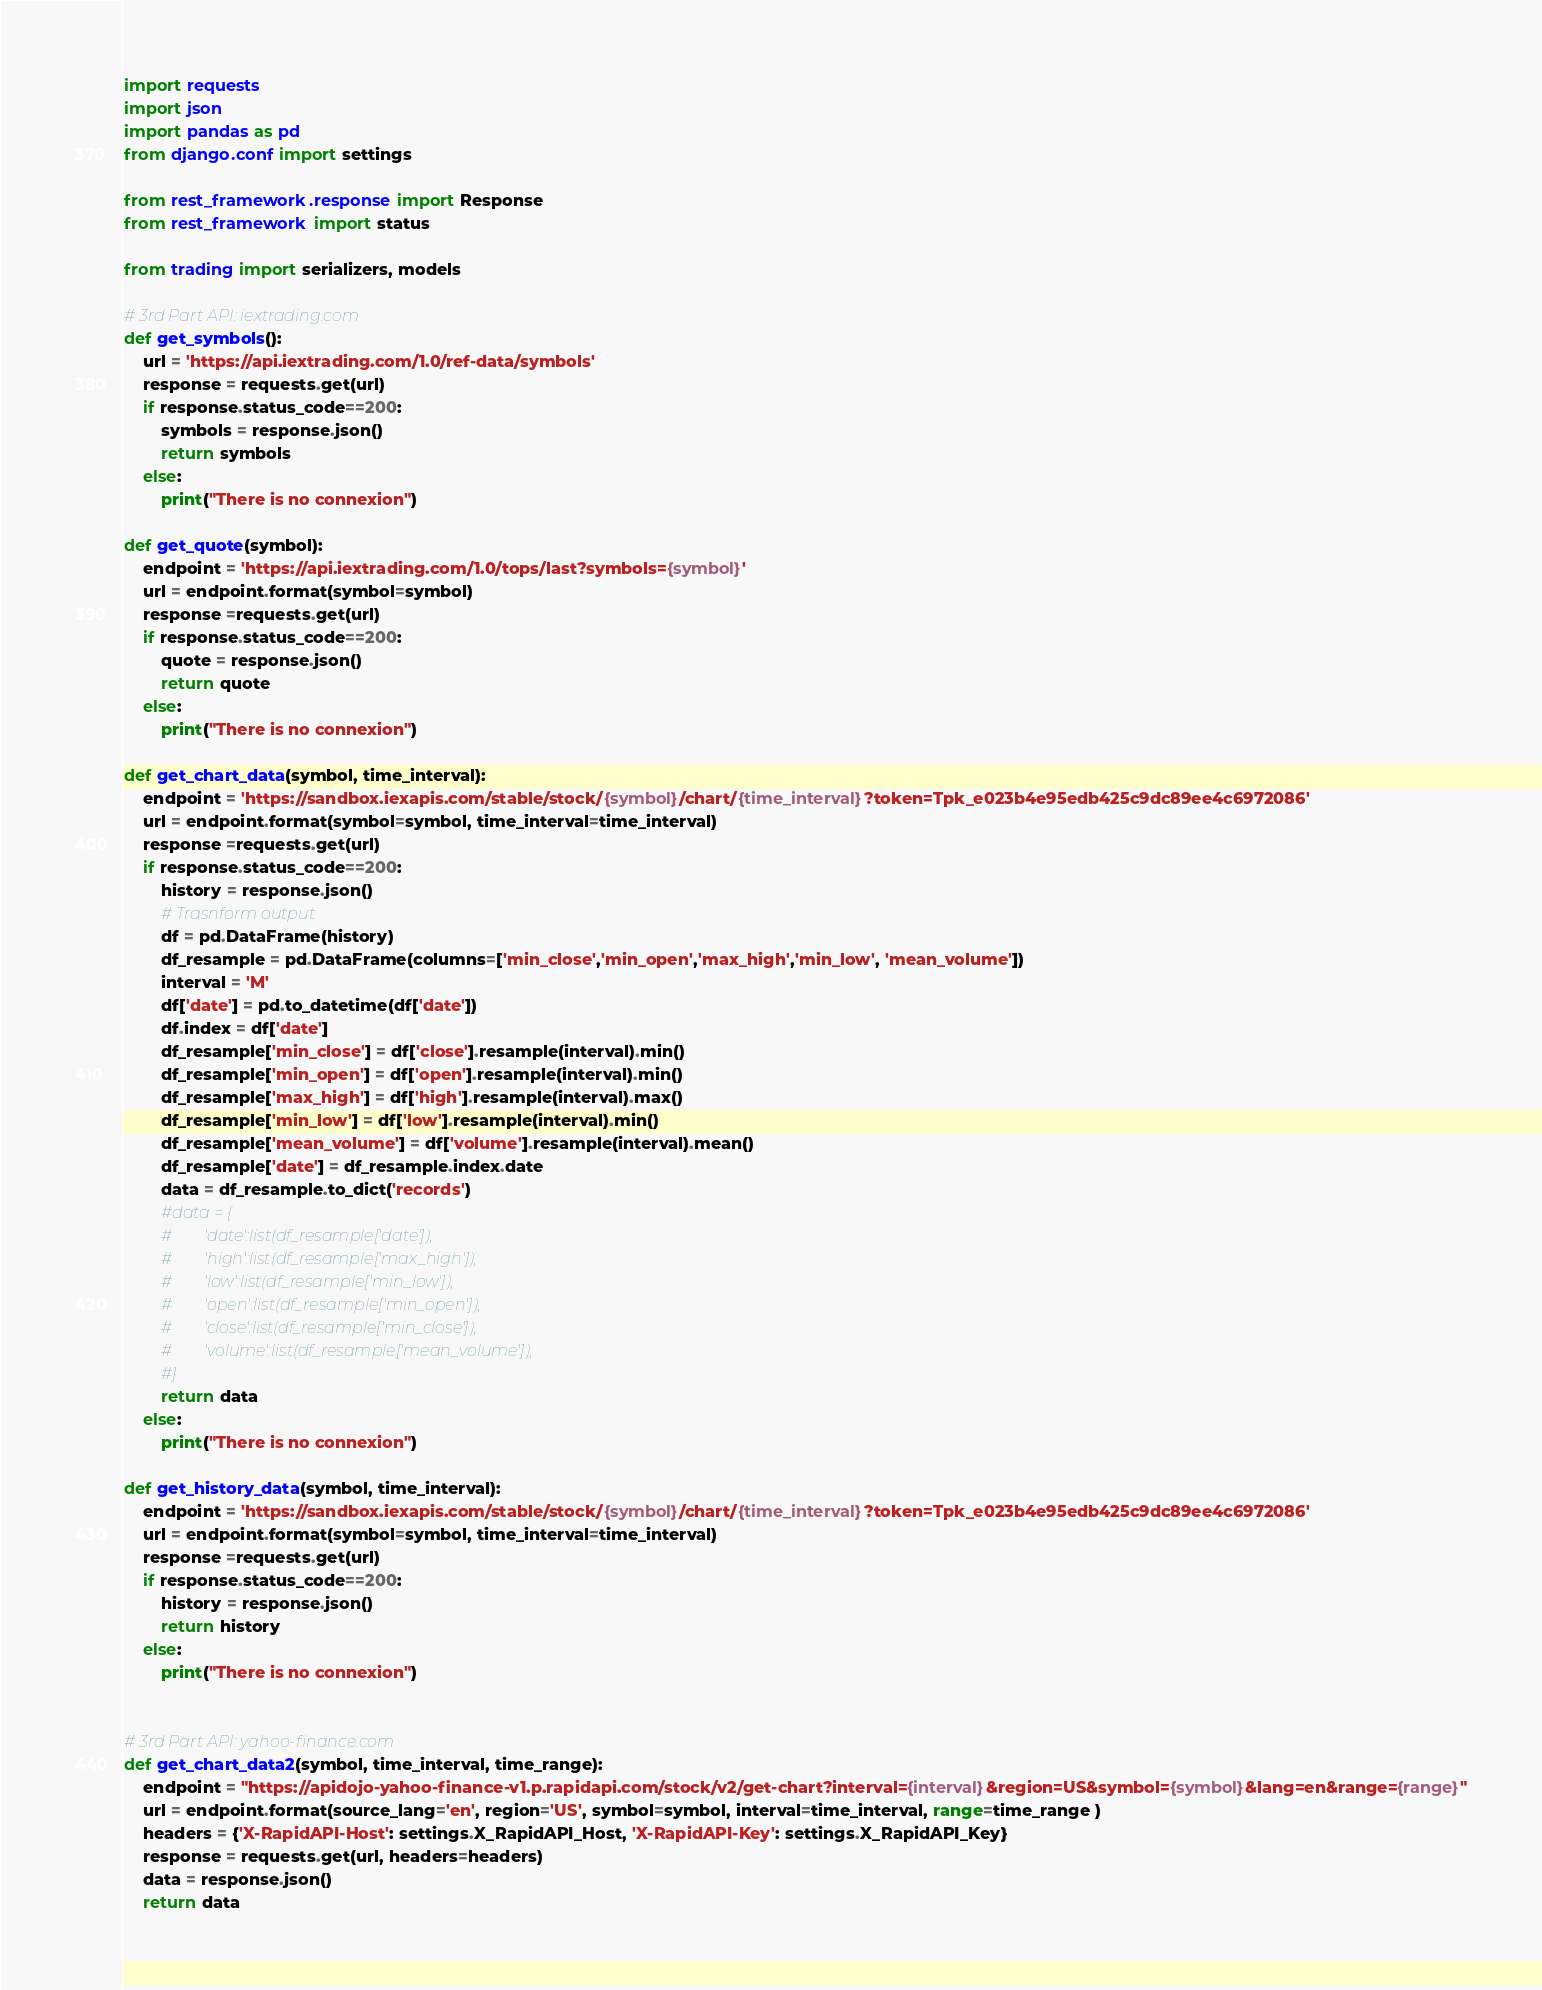Convert code to text. <code><loc_0><loc_0><loc_500><loc_500><_Python_>import requests
import json
import pandas as pd
from django.conf import settings

from rest_framework.response import Response
from rest_framework import status

from trading import serializers, models

# 3rd Part API: iextrading.com
def get_symbols():
    url = 'https://api.iextrading.com/1.0/ref-data/symbols'
    response = requests.get(url)
    if response.status_code==200:
        symbols = response.json()
        return symbols
    else:
        print("There is no connexion")

def get_quote(symbol):
    endpoint = 'https://api.iextrading.com/1.0/tops/last?symbols={symbol}'
    url = endpoint.format(symbol=symbol)
    response =requests.get(url)
    if response.status_code==200:
        quote = response.json()
        return quote
    else:
        print("There is no connexion")

def get_chart_data(symbol, time_interval):
    endpoint = 'https://sandbox.iexapis.com/stable/stock/{symbol}/chart/{time_interval}?token=Tpk_e023b4e95edb425c9dc89ee4c6972086'
    url = endpoint.format(symbol=symbol, time_interval=time_interval)
    response =requests.get(url)
    if response.status_code==200:
        history = response.json()
        # Trasnform output
        df = pd.DataFrame(history)
        df_resample = pd.DataFrame(columns=['min_close','min_open','max_high','min_low', 'mean_volume'])
        interval = 'M'
        df['date'] = pd.to_datetime(df['date'])
        df.index = df['date'] 
        df_resample['min_close'] = df['close'].resample(interval).min()
        df_resample['min_open'] = df['open'].resample(interval).min()
        df_resample['max_high'] = df['high'].resample(interval).max()
        df_resample['min_low'] = df['low'].resample(interval).min()
        df_resample['mean_volume'] = df['volume'].resample(interval).mean()
        df_resample['date'] = df_resample.index.date
        data = df_resample.to_dict('records')
        #data = {
        #        'date':list(df_resample['date']),
        #        'high':list(df_resample['max_high']),
        #        'low':list(df_resample['min_low']),
        #        'open':list(df_resample['min_open']),
        #        'close':list(df_resample['min_close']),
        #        'volume':list(df_resample['mean_volume']),
        #}
        return data
    else:
        print("There is no connexion")

def get_history_data(symbol, time_interval):
    endpoint = 'https://sandbox.iexapis.com/stable/stock/{symbol}/chart/{time_interval}?token=Tpk_e023b4e95edb425c9dc89ee4c6972086'
    url = endpoint.format(symbol=symbol, time_interval=time_interval)
    response =requests.get(url)
    if response.status_code==200:
        history = response.json()
        return history
    else:
        print("There is no connexion")


# 3rd Part API: yahoo-finance.com
def get_chart_data2(symbol, time_interval, time_range):
    endpoint = "https://apidojo-yahoo-finance-v1.p.rapidapi.com/stock/v2/get-chart?interval={interval}&region=US&symbol={symbol}&lang=en&range={range}"
    url = endpoint.format(source_lang='en', region='US', symbol=symbol, interval=time_interval, range=time_range )
    headers = {'X-RapidAPI-Host': settings.X_RapidAPI_Host, 'X-RapidAPI-Key': settings.X_RapidAPI_Key}
    response = requests.get(url, headers=headers)
    data = response.json()
    return data</code> 